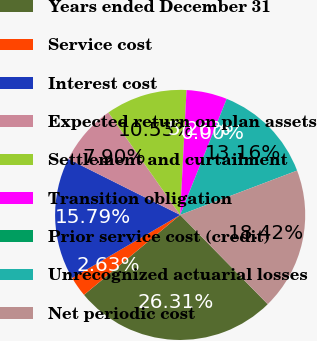Convert chart to OTSL. <chart><loc_0><loc_0><loc_500><loc_500><pie_chart><fcel>Years ended December 31<fcel>Service cost<fcel>Interest cost<fcel>Expected return on plan assets<fcel>Settlement and curtailment<fcel>Transition obligation<fcel>Prior service cost (credit)<fcel>Unrecognized actuarial losses<fcel>Net periodic cost<nl><fcel>26.31%<fcel>2.63%<fcel>15.79%<fcel>7.9%<fcel>10.53%<fcel>5.26%<fcel>0.0%<fcel>13.16%<fcel>18.42%<nl></chart> 